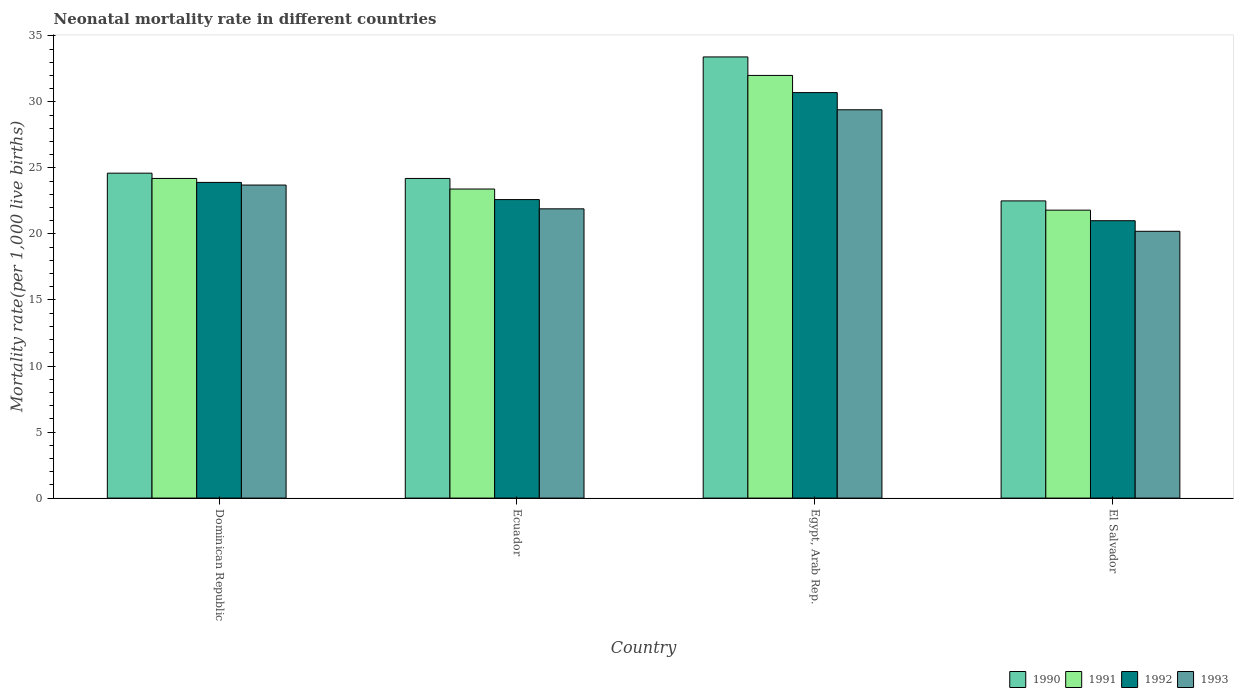How many different coloured bars are there?
Give a very brief answer. 4. How many groups of bars are there?
Provide a succinct answer. 4. How many bars are there on the 4th tick from the left?
Provide a short and direct response. 4. How many bars are there on the 4th tick from the right?
Offer a terse response. 4. What is the label of the 2nd group of bars from the left?
Keep it short and to the point. Ecuador. In how many cases, is the number of bars for a given country not equal to the number of legend labels?
Offer a terse response. 0. Across all countries, what is the maximum neonatal mortality rate in 1993?
Ensure brevity in your answer.  29.4. In which country was the neonatal mortality rate in 1992 maximum?
Give a very brief answer. Egypt, Arab Rep. In which country was the neonatal mortality rate in 1993 minimum?
Make the answer very short. El Salvador. What is the total neonatal mortality rate in 1990 in the graph?
Your answer should be compact. 104.7. What is the difference between the neonatal mortality rate in 1991 in Dominican Republic and that in Ecuador?
Your answer should be very brief. 0.8. What is the difference between the neonatal mortality rate in 1991 in El Salvador and the neonatal mortality rate in 1993 in Ecuador?
Make the answer very short. -0.1. What is the average neonatal mortality rate in 1993 per country?
Your response must be concise. 23.8. What is the difference between the neonatal mortality rate of/in 1991 and neonatal mortality rate of/in 1992 in El Salvador?
Offer a terse response. 0.8. In how many countries, is the neonatal mortality rate in 1991 greater than 9?
Offer a very short reply. 4. What is the ratio of the neonatal mortality rate in 1992 in Egypt, Arab Rep. to that in El Salvador?
Your response must be concise. 1.46. What is the difference between the highest and the second highest neonatal mortality rate in 1992?
Ensure brevity in your answer.  -8.1. What is the difference between the highest and the lowest neonatal mortality rate in 1991?
Your answer should be compact. 10.2. In how many countries, is the neonatal mortality rate in 1993 greater than the average neonatal mortality rate in 1993 taken over all countries?
Provide a succinct answer. 1. Is it the case that in every country, the sum of the neonatal mortality rate in 1992 and neonatal mortality rate in 1993 is greater than the sum of neonatal mortality rate in 1991 and neonatal mortality rate in 1990?
Ensure brevity in your answer.  No. What does the 1st bar from the right in Ecuador represents?
Your response must be concise. 1993. Is it the case that in every country, the sum of the neonatal mortality rate in 1992 and neonatal mortality rate in 1993 is greater than the neonatal mortality rate in 1991?
Keep it short and to the point. Yes. How many bars are there?
Offer a terse response. 16. How many countries are there in the graph?
Your response must be concise. 4. What is the difference between two consecutive major ticks on the Y-axis?
Make the answer very short. 5. Where does the legend appear in the graph?
Offer a terse response. Bottom right. How many legend labels are there?
Make the answer very short. 4. What is the title of the graph?
Make the answer very short. Neonatal mortality rate in different countries. What is the label or title of the Y-axis?
Your answer should be compact. Mortality rate(per 1,0 live births). What is the Mortality rate(per 1,000 live births) in 1990 in Dominican Republic?
Offer a terse response. 24.6. What is the Mortality rate(per 1,000 live births) in 1991 in Dominican Republic?
Offer a very short reply. 24.2. What is the Mortality rate(per 1,000 live births) of 1992 in Dominican Republic?
Offer a very short reply. 23.9. What is the Mortality rate(per 1,000 live births) in 1993 in Dominican Republic?
Offer a terse response. 23.7. What is the Mortality rate(per 1,000 live births) in 1990 in Ecuador?
Your response must be concise. 24.2. What is the Mortality rate(per 1,000 live births) in 1991 in Ecuador?
Provide a short and direct response. 23.4. What is the Mortality rate(per 1,000 live births) of 1992 in Ecuador?
Your answer should be very brief. 22.6. What is the Mortality rate(per 1,000 live births) in 1993 in Ecuador?
Give a very brief answer. 21.9. What is the Mortality rate(per 1,000 live births) of 1990 in Egypt, Arab Rep.?
Offer a very short reply. 33.4. What is the Mortality rate(per 1,000 live births) in 1992 in Egypt, Arab Rep.?
Offer a very short reply. 30.7. What is the Mortality rate(per 1,000 live births) in 1993 in Egypt, Arab Rep.?
Your answer should be very brief. 29.4. What is the Mortality rate(per 1,000 live births) in 1991 in El Salvador?
Give a very brief answer. 21.8. What is the Mortality rate(per 1,000 live births) of 1993 in El Salvador?
Provide a short and direct response. 20.2. Across all countries, what is the maximum Mortality rate(per 1,000 live births) of 1990?
Provide a short and direct response. 33.4. Across all countries, what is the maximum Mortality rate(per 1,000 live births) of 1992?
Offer a very short reply. 30.7. Across all countries, what is the maximum Mortality rate(per 1,000 live births) in 1993?
Your answer should be compact. 29.4. Across all countries, what is the minimum Mortality rate(per 1,000 live births) of 1991?
Provide a short and direct response. 21.8. Across all countries, what is the minimum Mortality rate(per 1,000 live births) of 1992?
Offer a terse response. 21. Across all countries, what is the minimum Mortality rate(per 1,000 live births) in 1993?
Keep it short and to the point. 20.2. What is the total Mortality rate(per 1,000 live births) in 1990 in the graph?
Provide a short and direct response. 104.7. What is the total Mortality rate(per 1,000 live births) in 1991 in the graph?
Your response must be concise. 101.4. What is the total Mortality rate(per 1,000 live births) in 1992 in the graph?
Make the answer very short. 98.2. What is the total Mortality rate(per 1,000 live births) of 1993 in the graph?
Your answer should be very brief. 95.2. What is the difference between the Mortality rate(per 1,000 live births) of 1991 in Dominican Republic and that in Ecuador?
Your response must be concise. 0.8. What is the difference between the Mortality rate(per 1,000 live births) of 1993 in Dominican Republic and that in Ecuador?
Provide a short and direct response. 1.8. What is the difference between the Mortality rate(per 1,000 live births) in 1990 in Dominican Republic and that in Egypt, Arab Rep.?
Provide a short and direct response. -8.8. What is the difference between the Mortality rate(per 1,000 live births) in 1990 in Dominican Republic and that in El Salvador?
Ensure brevity in your answer.  2.1. What is the difference between the Mortality rate(per 1,000 live births) of 1992 in Ecuador and that in Egypt, Arab Rep.?
Make the answer very short. -8.1. What is the difference between the Mortality rate(per 1,000 live births) of 1992 in Ecuador and that in El Salvador?
Offer a very short reply. 1.6. What is the difference between the Mortality rate(per 1,000 live births) of 1993 in Ecuador and that in El Salvador?
Ensure brevity in your answer.  1.7. What is the difference between the Mortality rate(per 1,000 live births) in 1990 in Dominican Republic and the Mortality rate(per 1,000 live births) in 1991 in Ecuador?
Offer a terse response. 1.2. What is the difference between the Mortality rate(per 1,000 live births) in 1990 in Dominican Republic and the Mortality rate(per 1,000 live births) in 1992 in Ecuador?
Ensure brevity in your answer.  2. What is the difference between the Mortality rate(per 1,000 live births) in 1990 in Dominican Republic and the Mortality rate(per 1,000 live births) in 1993 in Ecuador?
Your response must be concise. 2.7. What is the difference between the Mortality rate(per 1,000 live births) in 1991 in Dominican Republic and the Mortality rate(per 1,000 live births) in 1992 in Ecuador?
Make the answer very short. 1.6. What is the difference between the Mortality rate(per 1,000 live births) in 1990 in Dominican Republic and the Mortality rate(per 1,000 live births) in 1993 in Egypt, Arab Rep.?
Make the answer very short. -4.8. What is the difference between the Mortality rate(per 1,000 live births) in 1991 in Dominican Republic and the Mortality rate(per 1,000 live births) in 1992 in Egypt, Arab Rep.?
Provide a short and direct response. -6.5. What is the difference between the Mortality rate(per 1,000 live births) of 1992 in Dominican Republic and the Mortality rate(per 1,000 live births) of 1993 in Egypt, Arab Rep.?
Make the answer very short. -5.5. What is the difference between the Mortality rate(per 1,000 live births) of 1990 in Dominican Republic and the Mortality rate(per 1,000 live births) of 1992 in El Salvador?
Offer a terse response. 3.6. What is the difference between the Mortality rate(per 1,000 live births) of 1990 in Dominican Republic and the Mortality rate(per 1,000 live births) of 1993 in El Salvador?
Keep it short and to the point. 4.4. What is the difference between the Mortality rate(per 1,000 live births) of 1991 in Dominican Republic and the Mortality rate(per 1,000 live births) of 1992 in El Salvador?
Give a very brief answer. 3.2. What is the difference between the Mortality rate(per 1,000 live births) of 1990 in Ecuador and the Mortality rate(per 1,000 live births) of 1991 in Egypt, Arab Rep.?
Your response must be concise. -7.8. What is the difference between the Mortality rate(per 1,000 live births) of 1990 in Ecuador and the Mortality rate(per 1,000 live births) of 1992 in Egypt, Arab Rep.?
Keep it short and to the point. -6.5. What is the difference between the Mortality rate(per 1,000 live births) in 1991 in Ecuador and the Mortality rate(per 1,000 live births) in 1993 in Egypt, Arab Rep.?
Your answer should be very brief. -6. What is the difference between the Mortality rate(per 1,000 live births) of 1990 in Ecuador and the Mortality rate(per 1,000 live births) of 1991 in El Salvador?
Your answer should be compact. 2.4. What is the difference between the Mortality rate(per 1,000 live births) of 1992 in Ecuador and the Mortality rate(per 1,000 live births) of 1993 in El Salvador?
Offer a very short reply. 2.4. What is the difference between the Mortality rate(per 1,000 live births) of 1990 in Egypt, Arab Rep. and the Mortality rate(per 1,000 live births) of 1991 in El Salvador?
Your answer should be very brief. 11.6. What is the difference between the Mortality rate(per 1,000 live births) of 1990 in Egypt, Arab Rep. and the Mortality rate(per 1,000 live births) of 1992 in El Salvador?
Provide a succinct answer. 12.4. What is the difference between the Mortality rate(per 1,000 live births) of 1990 in Egypt, Arab Rep. and the Mortality rate(per 1,000 live births) of 1993 in El Salvador?
Offer a terse response. 13.2. What is the difference between the Mortality rate(per 1,000 live births) of 1991 in Egypt, Arab Rep. and the Mortality rate(per 1,000 live births) of 1992 in El Salvador?
Your response must be concise. 11. What is the average Mortality rate(per 1,000 live births) of 1990 per country?
Give a very brief answer. 26.18. What is the average Mortality rate(per 1,000 live births) of 1991 per country?
Offer a very short reply. 25.35. What is the average Mortality rate(per 1,000 live births) of 1992 per country?
Ensure brevity in your answer.  24.55. What is the average Mortality rate(per 1,000 live births) of 1993 per country?
Keep it short and to the point. 23.8. What is the difference between the Mortality rate(per 1,000 live births) in 1991 and Mortality rate(per 1,000 live births) in 1992 in Dominican Republic?
Ensure brevity in your answer.  0.3. What is the difference between the Mortality rate(per 1,000 live births) in 1992 and Mortality rate(per 1,000 live births) in 1993 in Dominican Republic?
Your answer should be compact. 0.2. What is the difference between the Mortality rate(per 1,000 live births) in 1990 and Mortality rate(per 1,000 live births) in 1992 in Ecuador?
Provide a succinct answer. 1.6. What is the difference between the Mortality rate(per 1,000 live births) in 1991 and Mortality rate(per 1,000 live births) in 1992 in Ecuador?
Provide a succinct answer. 0.8. What is the difference between the Mortality rate(per 1,000 live births) of 1991 and Mortality rate(per 1,000 live births) of 1993 in Ecuador?
Provide a short and direct response. 1.5. What is the difference between the Mortality rate(per 1,000 live births) of 1992 and Mortality rate(per 1,000 live births) of 1993 in Ecuador?
Offer a terse response. 0.7. What is the difference between the Mortality rate(per 1,000 live births) in 1990 and Mortality rate(per 1,000 live births) in 1992 in Egypt, Arab Rep.?
Give a very brief answer. 2.7. What is the difference between the Mortality rate(per 1,000 live births) of 1990 and Mortality rate(per 1,000 live births) of 1991 in El Salvador?
Give a very brief answer. 0.7. What is the difference between the Mortality rate(per 1,000 live births) in 1990 and Mortality rate(per 1,000 live births) in 1992 in El Salvador?
Your response must be concise. 1.5. What is the difference between the Mortality rate(per 1,000 live births) of 1991 and Mortality rate(per 1,000 live births) of 1992 in El Salvador?
Your answer should be compact. 0.8. What is the difference between the Mortality rate(per 1,000 live births) of 1991 and Mortality rate(per 1,000 live births) of 1993 in El Salvador?
Your answer should be very brief. 1.6. What is the difference between the Mortality rate(per 1,000 live births) of 1992 and Mortality rate(per 1,000 live births) of 1993 in El Salvador?
Your answer should be compact. 0.8. What is the ratio of the Mortality rate(per 1,000 live births) of 1990 in Dominican Republic to that in Ecuador?
Keep it short and to the point. 1.02. What is the ratio of the Mortality rate(per 1,000 live births) of 1991 in Dominican Republic to that in Ecuador?
Give a very brief answer. 1.03. What is the ratio of the Mortality rate(per 1,000 live births) of 1992 in Dominican Republic to that in Ecuador?
Give a very brief answer. 1.06. What is the ratio of the Mortality rate(per 1,000 live births) in 1993 in Dominican Republic to that in Ecuador?
Provide a short and direct response. 1.08. What is the ratio of the Mortality rate(per 1,000 live births) in 1990 in Dominican Republic to that in Egypt, Arab Rep.?
Keep it short and to the point. 0.74. What is the ratio of the Mortality rate(per 1,000 live births) of 1991 in Dominican Republic to that in Egypt, Arab Rep.?
Ensure brevity in your answer.  0.76. What is the ratio of the Mortality rate(per 1,000 live births) in 1992 in Dominican Republic to that in Egypt, Arab Rep.?
Provide a succinct answer. 0.78. What is the ratio of the Mortality rate(per 1,000 live births) of 1993 in Dominican Republic to that in Egypt, Arab Rep.?
Make the answer very short. 0.81. What is the ratio of the Mortality rate(per 1,000 live births) in 1990 in Dominican Republic to that in El Salvador?
Give a very brief answer. 1.09. What is the ratio of the Mortality rate(per 1,000 live births) in 1991 in Dominican Republic to that in El Salvador?
Your answer should be compact. 1.11. What is the ratio of the Mortality rate(per 1,000 live births) of 1992 in Dominican Republic to that in El Salvador?
Keep it short and to the point. 1.14. What is the ratio of the Mortality rate(per 1,000 live births) in 1993 in Dominican Republic to that in El Salvador?
Provide a succinct answer. 1.17. What is the ratio of the Mortality rate(per 1,000 live births) in 1990 in Ecuador to that in Egypt, Arab Rep.?
Your answer should be compact. 0.72. What is the ratio of the Mortality rate(per 1,000 live births) of 1991 in Ecuador to that in Egypt, Arab Rep.?
Your response must be concise. 0.73. What is the ratio of the Mortality rate(per 1,000 live births) of 1992 in Ecuador to that in Egypt, Arab Rep.?
Provide a short and direct response. 0.74. What is the ratio of the Mortality rate(per 1,000 live births) in 1993 in Ecuador to that in Egypt, Arab Rep.?
Your response must be concise. 0.74. What is the ratio of the Mortality rate(per 1,000 live births) of 1990 in Ecuador to that in El Salvador?
Your answer should be compact. 1.08. What is the ratio of the Mortality rate(per 1,000 live births) of 1991 in Ecuador to that in El Salvador?
Offer a terse response. 1.07. What is the ratio of the Mortality rate(per 1,000 live births) in 1992 in Ecuador to that in El Salvador?
Give a very brief answer. 1.08. What is the ratio of the Mortality rate(per 1,000 live births) in 1993 in Ecuador to that in El Salvador?
Your answer should be compact. 1.08. What is the ratio of the Mortality rate(per 1,000 live births) of 1990 in Egypt, Arab Rep. to that in El Salvador?
Offer a terse response. 1.48. What is the ratio of the Mortality rate(per 1,000 live births) of 1991 in Egypt, Arab Rep. to that in El Salvador?
Make the answer very short. 1.47. What is the ratio of the Mortality rate(per 1,000 live births) in 1992 in Egypt, Arab Rep. to that in El Salvador?
Offer a very short reply. 1.46. What is the ratio of the Mortality rate(per 1,000 live births) of 1993 in Egypt, Arab Rep. to that in El Salvador?
Your answer should be compact. 1.46. What is the difference between the highest and the second highest Mortality rate(per 1,000 live births) in 1990?
Offer a very short reply. 8.8. What is the difference between the highest and the second highest Mortality rate(per 1,000 live births) in 1993?
Provide a short and direct response. 5.7. What is the difference between the highest and the lowest Mortality rate(per 1,000 live births) in 1991?
Provide a succinct answer. 10.2. What is the difference between the highest and the lowest Mortality rate(per 1,000 live births) in 1992?
Ensure brevity in your answer.  9.7. What is the difference between the highest and the lowest Mortality rate(per 1,000 live births) of 1993?
Provide a short and direct response. 9.2. 